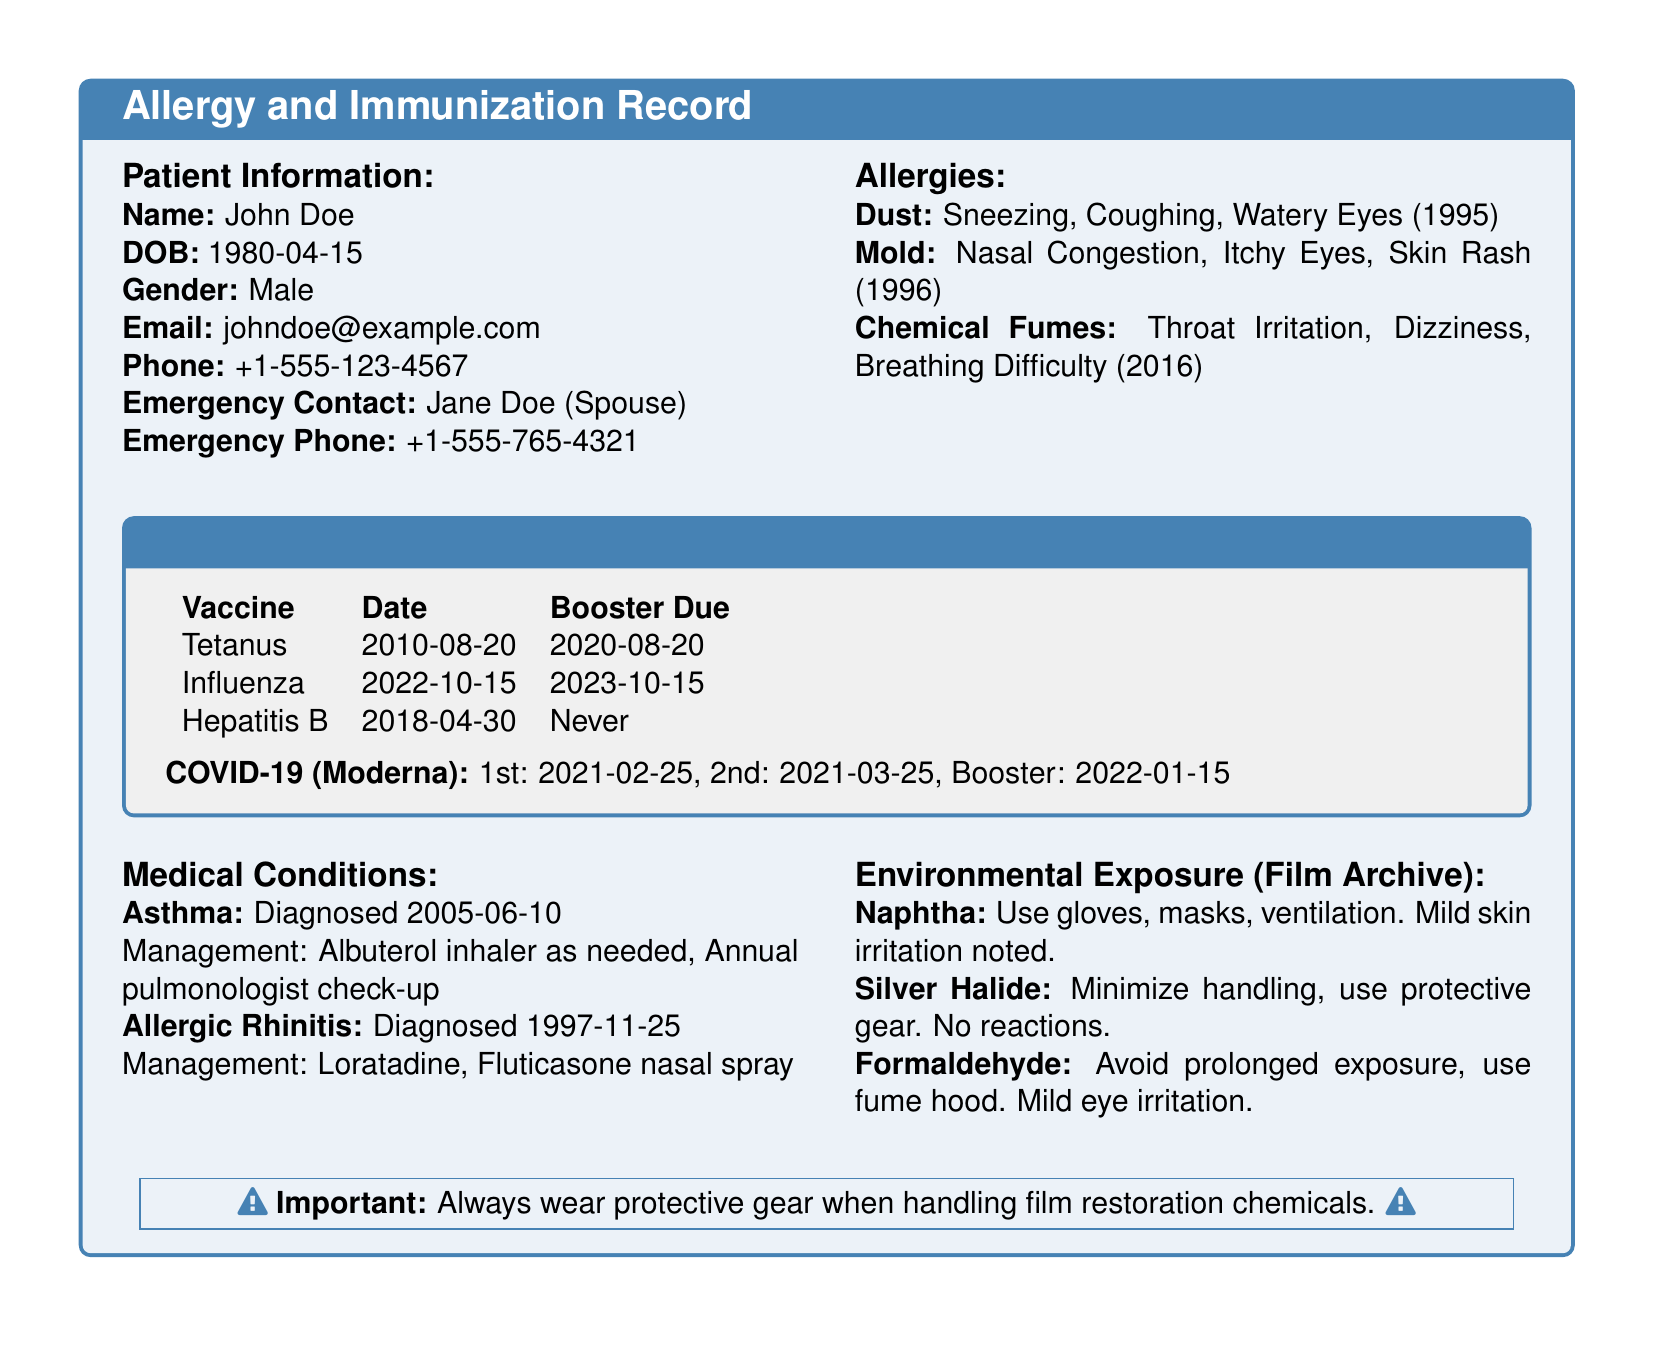What is the patient's name? The patient's name is provided in the Patient Information section of the document.
Answer: John Doe What kind of allergy reaction does the patient have to dust? The reaction to dust is detailed in the Allergies section.
Answer: Sneezing, Coughing, Watery Eyes When was the last Influenza vaccination? The date of the last Influenza vaccination can be found in the Immunization History section.
Answer: 2022-10-15 What precautions are suggested for handling Naphtha? The Environmental Exposure section outlines precautions for Naphtha.
Answer: Use gloves, masks, ventilation Which medical condition was diagnosed first? This requires reasoning between the dates of diagnosis listed under Medical Conditions.
Answer: Allergic Rhinitis What is the due date for the next Tetanus booster? This date is specified in the Immunization History section.
Answer: 2020-08-20 What mild irritation is noted for Formaldehyde exposure? The type of irritation is listed in the Environmental Exposure section.
Answer: Mild eye irritation What is the management for Asthma? Management details for Asthma are provided in the Medical Conditions section.
Answer: Albuterol inhaler as needed, Annual pulmonologist check-up 